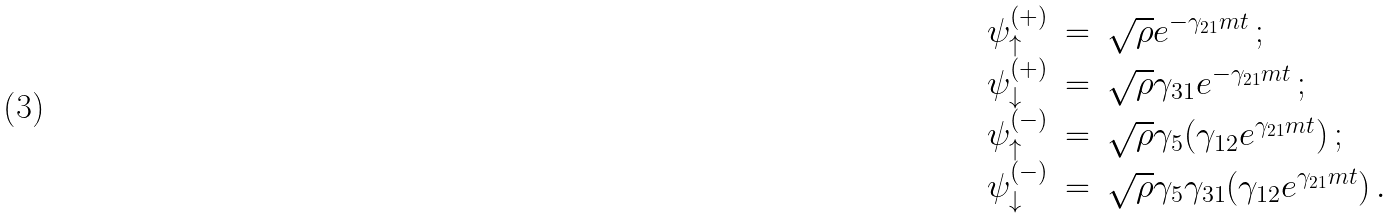Convert formula to latex. <formula><loc_0><loc_0><loc_500><loc_500>\begin{array} { r c l } \psi ^ { ( + ) } _ { \uparrow } & = & \sqrt { \rho } e ^ { - \gamma _ { 2 1 } m t } \, ; \\ \psi ^ { ( + ) } _ { \downarrow } & = & \sqrt { \rho } \gamma _ { 3 1 } e ^ { - \gamma _ { 2 1 } m t } \, ; \\ \psi ^ { ( - ) } _ { \uparrow } & = & \sqrt { \rho } \gamma _ { 5 } ( \gamma _ { 1 2 } e ^ { \gamma _ { 2 1 } m t } ) \, ; \\ \psi ^ { ( - ) } _ { \downarrow } & = & \sqrt { \rho } \gamma _ { 5 } \gamma _ { 3 1 } ( \gamma _ { 1 2 } e ^ { \gamma _ { 2 1 } m t } ) \, . \end{array}</formula> 